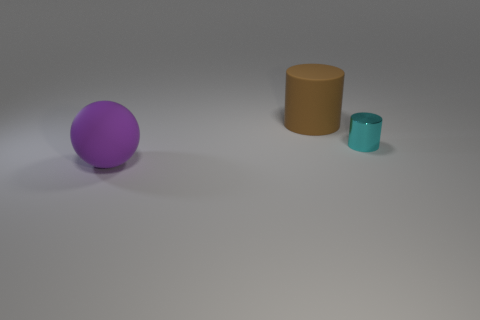What shape is the object that is to the right of the large matte thing that is behind the large purple ball?
Your answer should be very brief. Cylinder. There is a small object; how many large matte objects are right of it?
Offer a very short reply. 0. Are there any small cyan cylinders made of the same material as the ball?
Keep it short and to the point. No. What is the material of the brown cylinder that is the same size as the sphere?
Make the answer very short. Rubber. There is a object that is both in front of the large brown cylinder and on the left side of the small thing; what size is it?
Make the answer very short. Large. What is the color of the object that is to the left of the cyan metallic cylinder and in front of the brown rubber thing?
Make the answer very short. Purple. Are there fewer cyan things that are on the left side of the large brown rubber cylinder than purple rubber objects that are behind the cyan thing?
Make the answer very short. No. What number of big matte things have the same shape as the tiny thing?
Offer a very short reply. 1. The cylinder that is made of the same material as the large purple ball is what size?
Keep it short and to the point. Large. There is a big object that is behind the large matte thing left of the large matte cylinder; what color is it?
Offer a very short reply. Brown. 